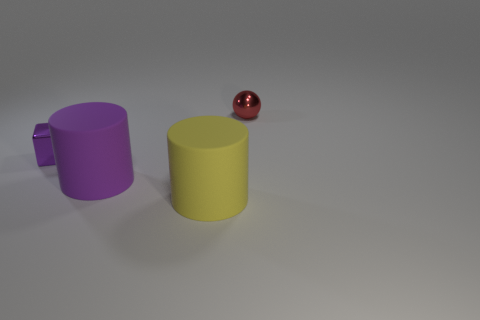Subtract all purple cylinders. How many cylinders are left? 1 Add 4 large purple shiny balls. How many objects exist? 8 Subtract 1 cubes. How many cubes are left? 0 Subtract all gray cubes. How many yellow cylinders are left? 1 Subtract all small shiny spheres. Subtract all big brown cylinders. How many objects are left? 3 Add 2 tiny metallic cubes. How many tiny metallic cubes are left? 3 Add 3 tiny red balls. How many tiny red balls exist? 4 Subtract 1 red balls. How many objects are left? 3 Subtract all blocks. How many objects are left? 3 Subtract all cyan blocks. Subtract all purple balls. How many blocks are left? 1 